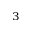Convert formula to latex. <formula><loc_0><loc_0><loc_500><loc_500>_ { 3 }</formula> 